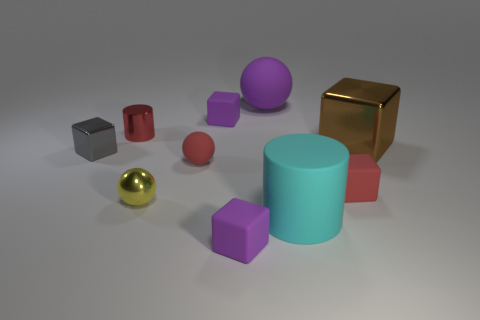Subtract all purple cubes. How many were subtracted if there are1purple cubes left? 1 Subtract 2 cubes. How many cubes are left? 3 Subtract all tiny red blocks. How many blocks are left? 4 Subtract all red cubes. How many cubes are left? 4 Subtract all green cubes. Subtract all green cylinders. How many cubes are left? 5 Subtract all balls. How many objects are left? 7 Add 7 small yellow rubber blocks. How many small yellow rubber blocks exist? 7 Subtract 0 gray cylinders. How many objects are left? 10 Subtract all gray cubes. Subtract all tiny spheres. How many objects are left? 7 Add 4 small balls. How many small balls are left? 6 